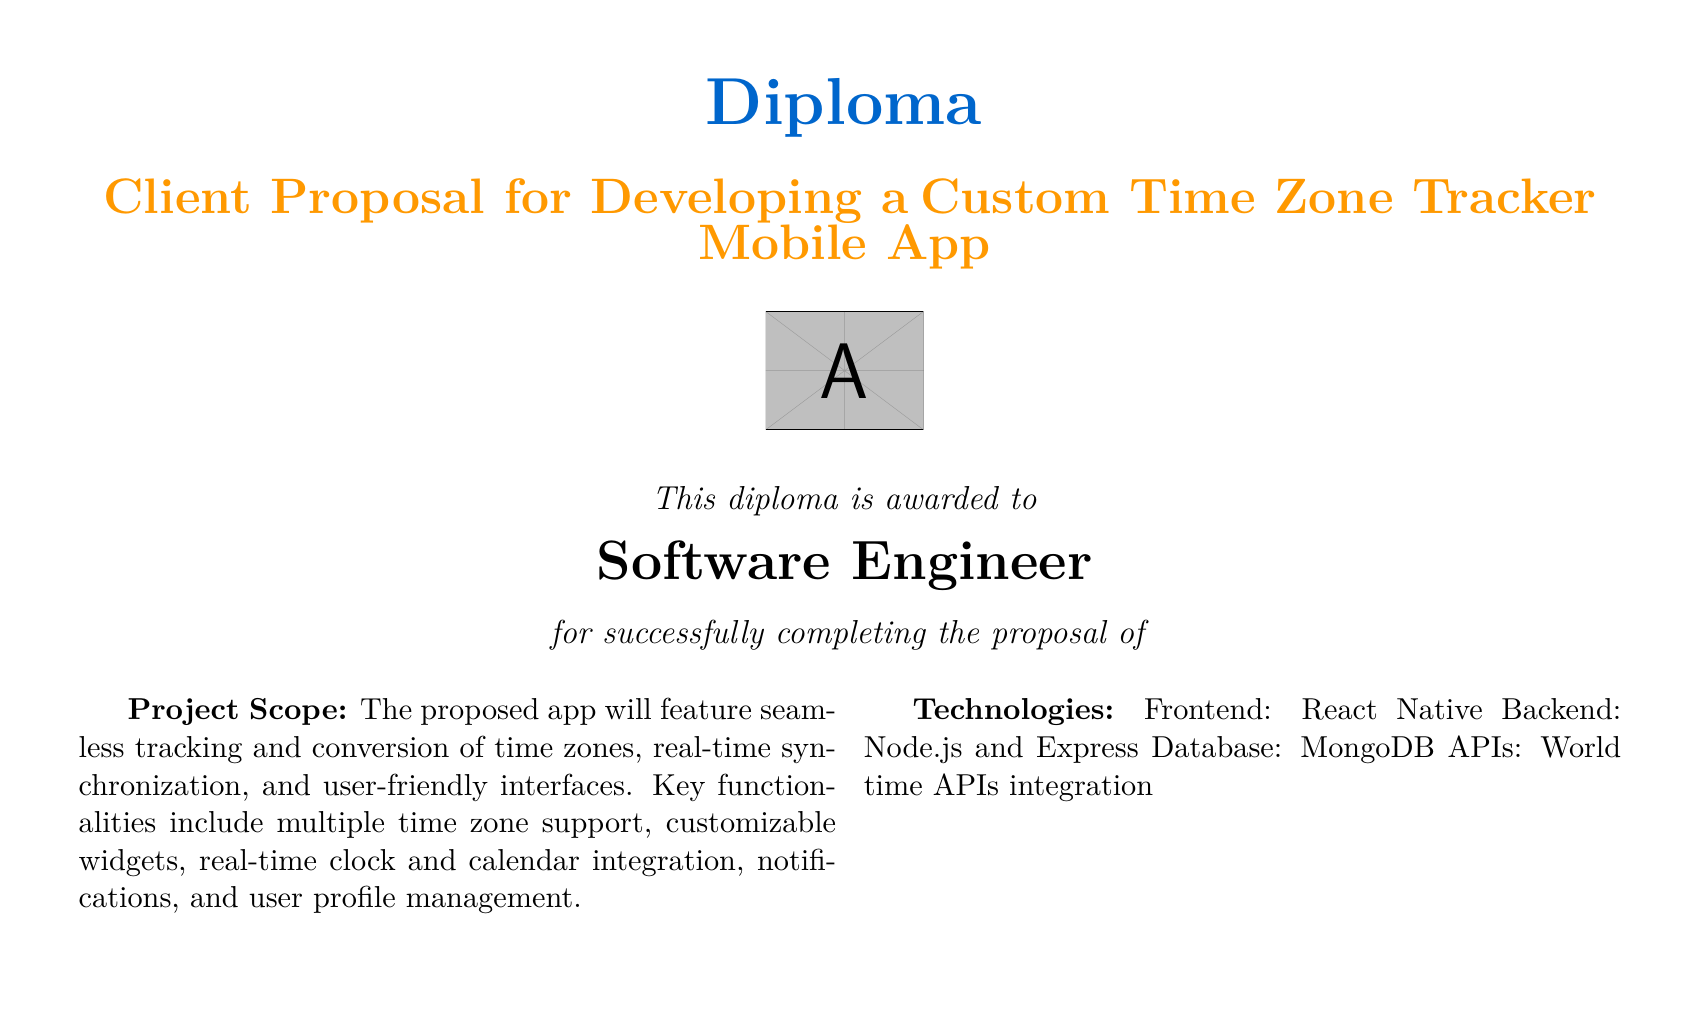What is the timeline for the project? The timeline details a total duration of 12 weeks, broken down into specific phases over this period.
Answer: 12 weeks What is the budget allocated for the project? The budget section lists the total amount set aside to complete the project.
Answer: $30,000 What technologies are used for the frontend? The technologies section specifies the framework chosen for the app's frontend development.
Answer: React Native What phase involves user testing? This phase comes after development and focuses on ensuring the app meets user expectations and is functional.
Answer: Beta Testing How much is allocated for design? The budget breakdown indicates the financial resources specifically set aside for the design phase.
Answer: $5,000 What is the main functionality of the proposed app? The project scope highlights the core purpose and feature set the app will provide to its users.
Answer: Time zone tracking and conversion Who is awarded this diploma? The document states the recipient's title and role related to the proposal.
Answer: Software Engineer How many weeks are dedicated to the design phase? By examining the timeline, one can identify the exact number of weeks assigned to design.
Answer: 3 weeks What is the total amount for testing? The budget section outlines the specific amount designated exclusively for testing the application.
Answer: $5,000 